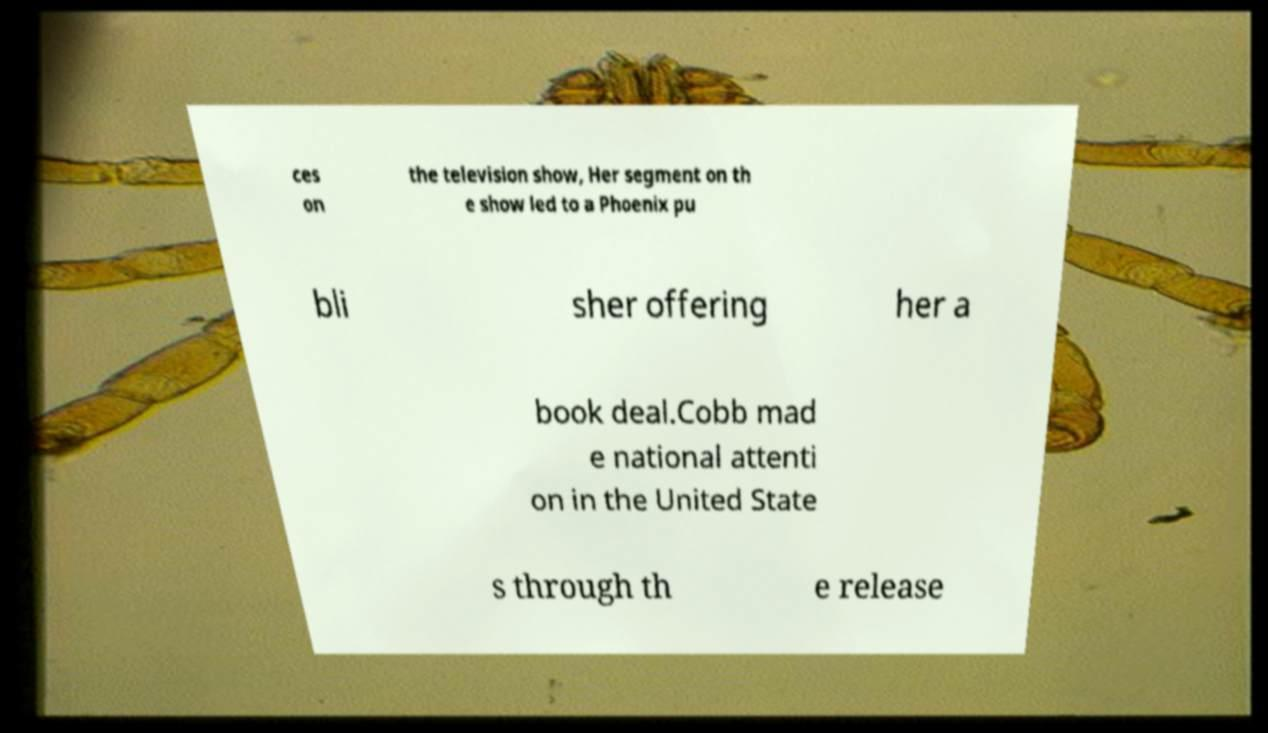Could you extract and type out the text from this image? ces on the television show, Her segment on th e show led to a Phoenix pu bli sher offering her a book deal.Cobb mad e national attenti on in the United State s through th e release 